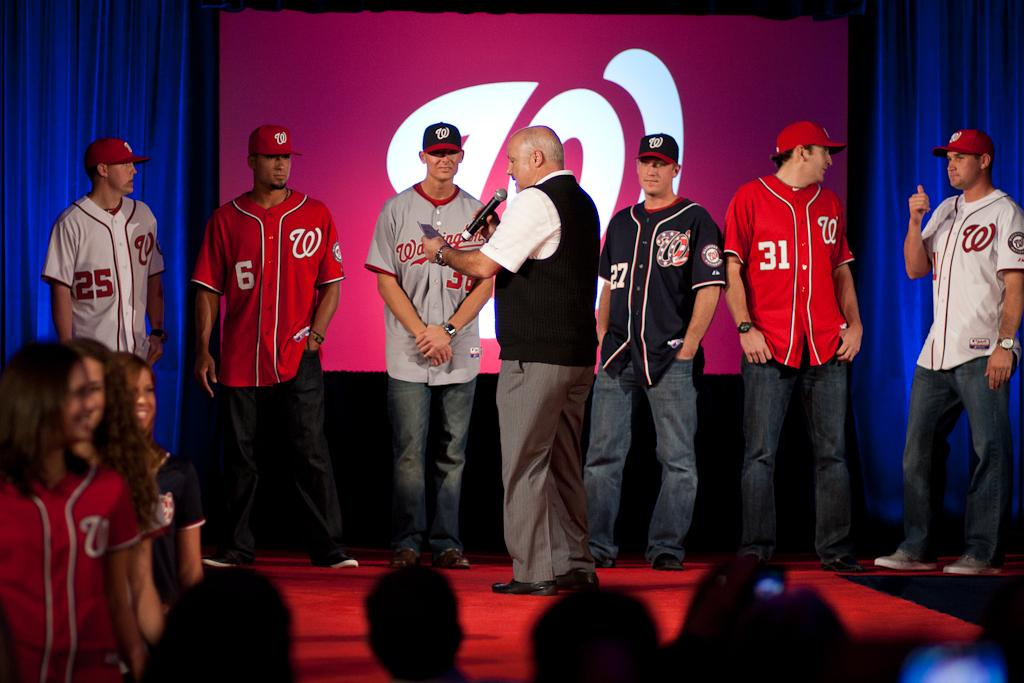Provide a one-sentence caption for the provided image. People in front of a presentation screen wear baseball jerseys with numbers like 25, 6, 27, and 31. 